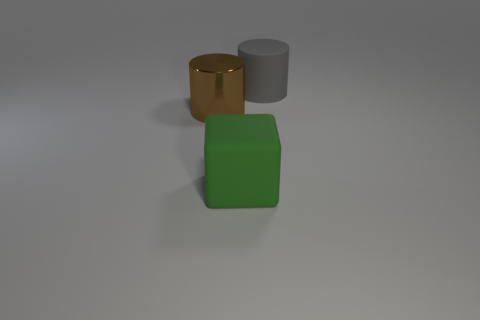Subtract 2 cylinders. How many cylinders are left? 0 Subtract all big green things. Subtract all big cyan things. How many objects are left? 2 Add 2 shiny cylinders. How many shiny cylinders are left? 3 Add 3 small blue balls. How many small blue balls exist? 3 Add 3 big green metal things. How many objects exist? 6 Subtract 0 gray cubes. How many objects are left? 3 Subtract all blocks. How many objects are left? 2 Subtract all gray cubes. Subtract all yellow cylinders. How many cubes are left? 1 Subtract all red blocks. How many green cylinders are left? 0 